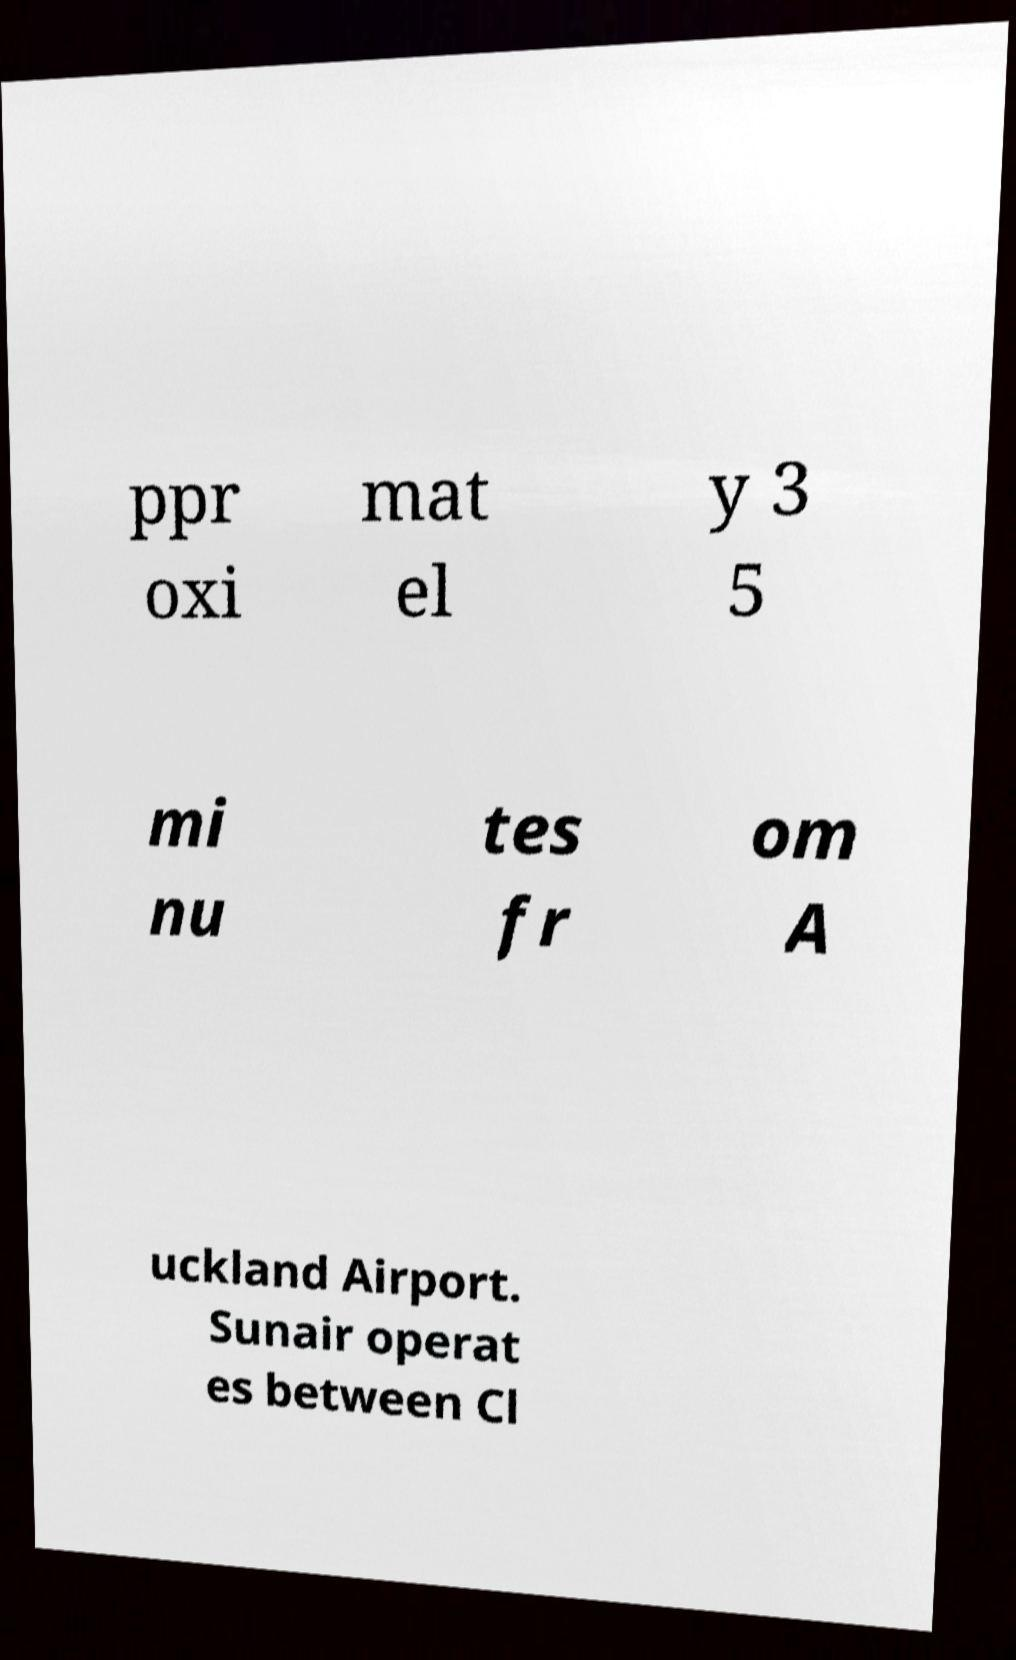Could you assist in decoding the text presented in this image and type it out clearly? ppr oxi mat el y 3 5 mi nu tes fr om A uckland Airport. Sunair operat es between Cl 